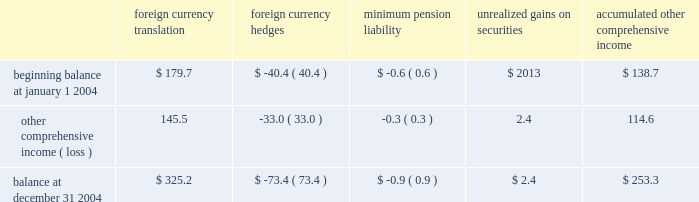Z i m m e r h o l d i n g s , i n c .
A n d s u b s i d i a r i e s 2 0 0 4 f o r m 1 0 - k notes to consolidated financial statements ( continued ) the components of accumulated other comprehensive income are as follows ( in millions ) : accumulated foreign foreign minimum unrealized other currency currency pension gains on comprehensive translation hedges liability securities income .
Accounting pronouncements 2013 in november 2004 , the no .
123 ( r ) requires all share-based payments to employees , fasb issued fasb staff position ( 2018 2018fsp 2019 2019 ) 109-1 , 2018 2018application including stock options , to be expensed based on their fair of fasb statement no .
109 , accounting for income taxes , to values .
The company has disclosed the effect on net earnings the tax deduction on qualified production activities and earnings per share if the company had applied the fair provided by the american jobs creation act of 2004 2019 2019 and value recognition provisions of sfas 123 .
Sfas 123 ( r ) fsp 109-2 , 2018 2018accounting and disclosure guidance for the contains three methodologies for adoption : 1 ) adopt foreign earnings repatriation provision within the american sfas 123 ( r ) on the effective date for interim periods jobs creation act of 2004 2019 2019 .
Fsp 109-1 states that a thereafter , 2 ) adopt sfas 123 ( r ) on the effective date for company 2019s deduction under the american jobs creation act interim periods thereafter and restate prior interim periods of 2004 ( the 2018 2018act 2019 2019 ) should be accounted for as a special included in the fiscal year of adoption under the provisions of deduction in accordance with sfas no .
109 and not as a tax sfas 123 , or 3 ) adopt sfas 123 ( r ) on the effective date for rate reduction .
Fsp 109-2 provides accounting and disclosure interim periods thereafter and restate all prior interim guidance for repatriation provisions included under the act .
Periods under the provisions of sfas 123 .
The company has fsp 109-1 and fsp 109-2 were both effective upon issuance .
Not determined an adoption methodology .
The company is in the adoption of these fsp 2019s did not have a material impact the process of assessing the impact that sfas 123 ( r ) will on the company 2019s financial position , results of operations or have on its financial position , results of operations and cash cash flows in 2004 .
Flows .
Sfas 123 ( r ) is effective for the company on july 1 , in november 2004 , the fasb issued sfas no .
151 , 2005 .
2018 2018inventory costs 2019 2019 to clarify the accounting for abnormal amounts of idle facility expense .
Sfas no .
151 requires that 3 .
Acquisitions fixed overhead production costs be applied to inventory at centerpulse ag and incentive capital ag 2018 2018normal capacity 2019 2019 and any excess fixed overhead production costs be charged to expense in the period in which they were on october 2 , 2003 ( the 2018 2018closing date 2019 2019 ) , the company incurred .
Sfas no .
151 is effective for fiscal years beginning closed its exchange offer for centerpulse , a global after june 15 , 2005 .
The company does not expect sfas orthopaedic medical device company headquartered in no .
151 to have a material impact on its financial position , switzerland that services the reconstructive joint , spine and results of operations , or cash flows .
Dental implant markets .
The company also closed its in december 2004 , the fasb issued sfas no .
153 , exchange offer for incentive , a company that , at the closing 2018 2018exchanges of nonmonetary assets 2019 2019 , which is effective for date , owned only cash and beneficially owned 18.3 percent of fiscal years beginning after june 15 , 2004 .
The company does the issued centerpulse shares .
The primary reason for not routinely engage in exchanges of nonmonetary assets ; as making the centerpulse and incentive exchange offers ( the such , sfas no .
153 is not expected to have a material impact 2018 2018exchange offers 2019 2019 ) was to create a global leader in the on the company 2019s financial position , results of operations or design , development , manufacture and marketing of cash flows .
Orthopaedic reconstructive implants , including joint and in may 2004 , the fasb issued fsp 106-2 2018 2018accounting dental , spine implants , and trauma products .
The strategic and disclosure requirements related to the medicare compatibility of the products and technologies of the prescription drug , improvement and modernization act of company and centerpulse is expected to provide significant 2003 2019 2019 , which is effective for the first interim or annual period earnings power and a strong platform from which it can beginning after june 15 , 2004 .
The company does not expect actively pursue growth opportunities in the industry .
For the to be eligible for the federal subsidy available pursuant to the company , centerpulse provides a unique platform for growth medicare prescription drug improvement and modernization and diversification in europe as well as in the spine and act of 2003 ; therefore , this staff position did not have a dental areas of the medical device industry .
As a result of the material impact on the company 2019s results of operations , exchange offers , the company beneficially owned financial position or cash flow .
98.7 percent of the issued centerpulse shares ( including the in december 2004 , the fasb issued sfas no .
123 ( r ) , centerpulse shares owned by incentive ) and 99.9 percent of 2018 2018share-based payment 2019 2019 , which is a revision to sfas no .
123 , the issued incentive shares on the closing date .
2018 2018accounting for stock based compensation 2019 2019 .
Sfas .
What was the percentage change in accumulated other comprehensive income for 2004? 
Computations: (114.6 / 138.7)
Answer: 0.82624. 